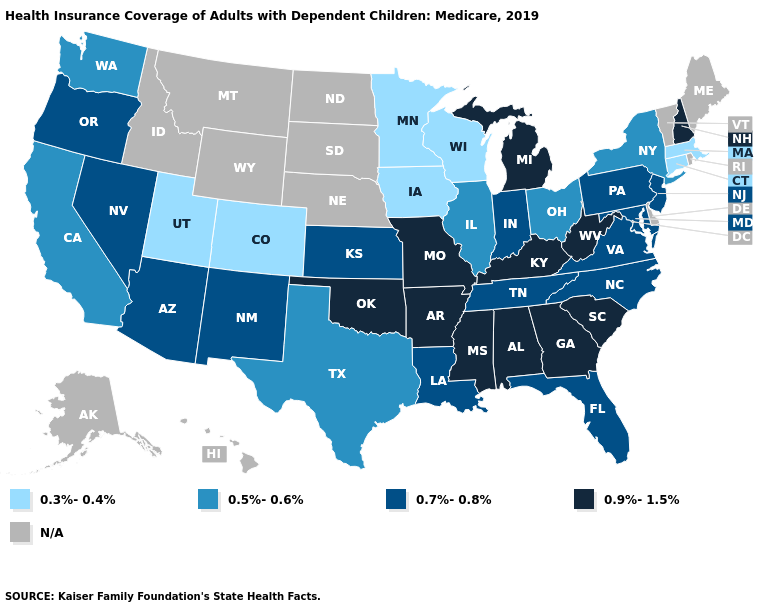Name the states that have a value in the range 0.3%-0.4%?
Keep it brief. Colorado, Connecticut, Iowa, Massachusetts, Minnesota, Utah, Wisconsin. Name the states that have a value in the range N/A?
Give a very brief answer. Alaska, Delaware, Hawaii, Idaho, Maine, Montana, Nebraska, North Dakota, Rhode Island, South Dakota, Vermont, Wyoming. Name the states that have a value in the range 0.9%-1.5%?
Quick response, please. Alabama, Arkansas, Georgia, Kentucky, Michigan, Mississippi, Missouri, New Hampshire, Oklahoma, South Carolina, West Virginia. What is the value of Montana?
Quick response, please. N/A. What is the value of Wyoming?
Concise answer only. N/A. Does South Carolina have the highest value in the South?
Concise answer only. Yes. Among the states that border Indiana , does Kentucky have the lowest value?
Be succinct. No. What is the highest value in the West ?
Concise answer only. 0.7%-0.8%. What is the lowest value in the MidWest?
Concise answer only. 0.3%-0.4%. Among the states that border Michigan , does Indiana have the highest value?
Be succinct. Yes. What is the highest value in states that border Washington?
Keep it brief. 0.7%-0.8%. Among the states that border Pennsylvania , does New York have the highest value?
Be succinct. No. What is the lowest value in the USA?
Short answer required. 0.3%-0.4%. Does New York have the lowest value in the Northeast?
Concise answer only. No. Which states have the lowest value in the Northeast?
Answer briefly. Connecticut, Massachusetts. 